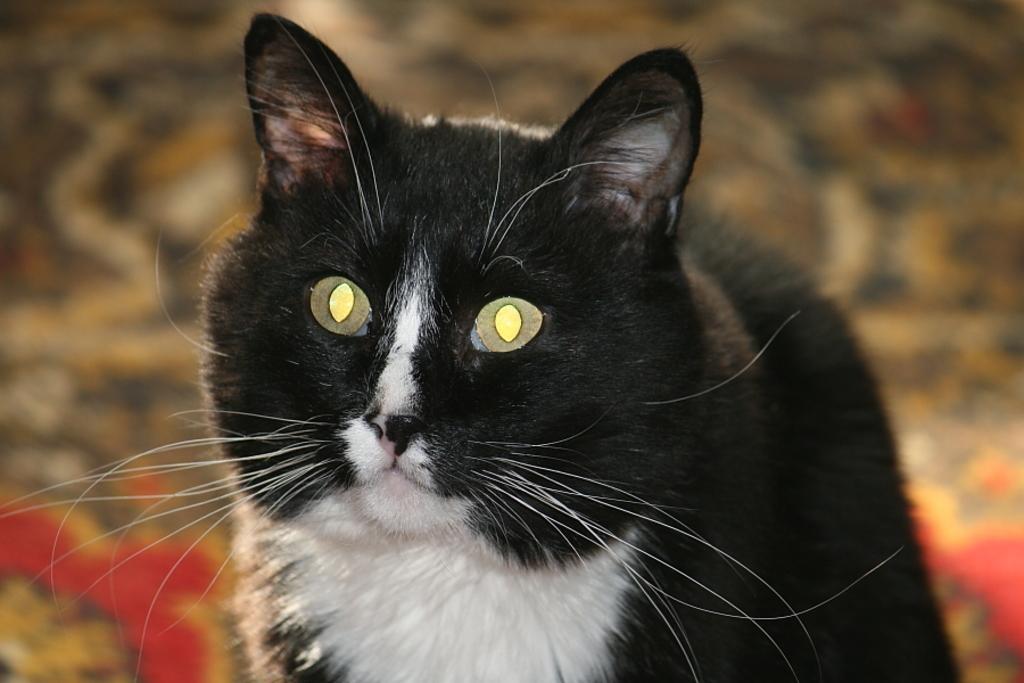Please provide a concise description of this image. In this image we can see a cat on the surface. 